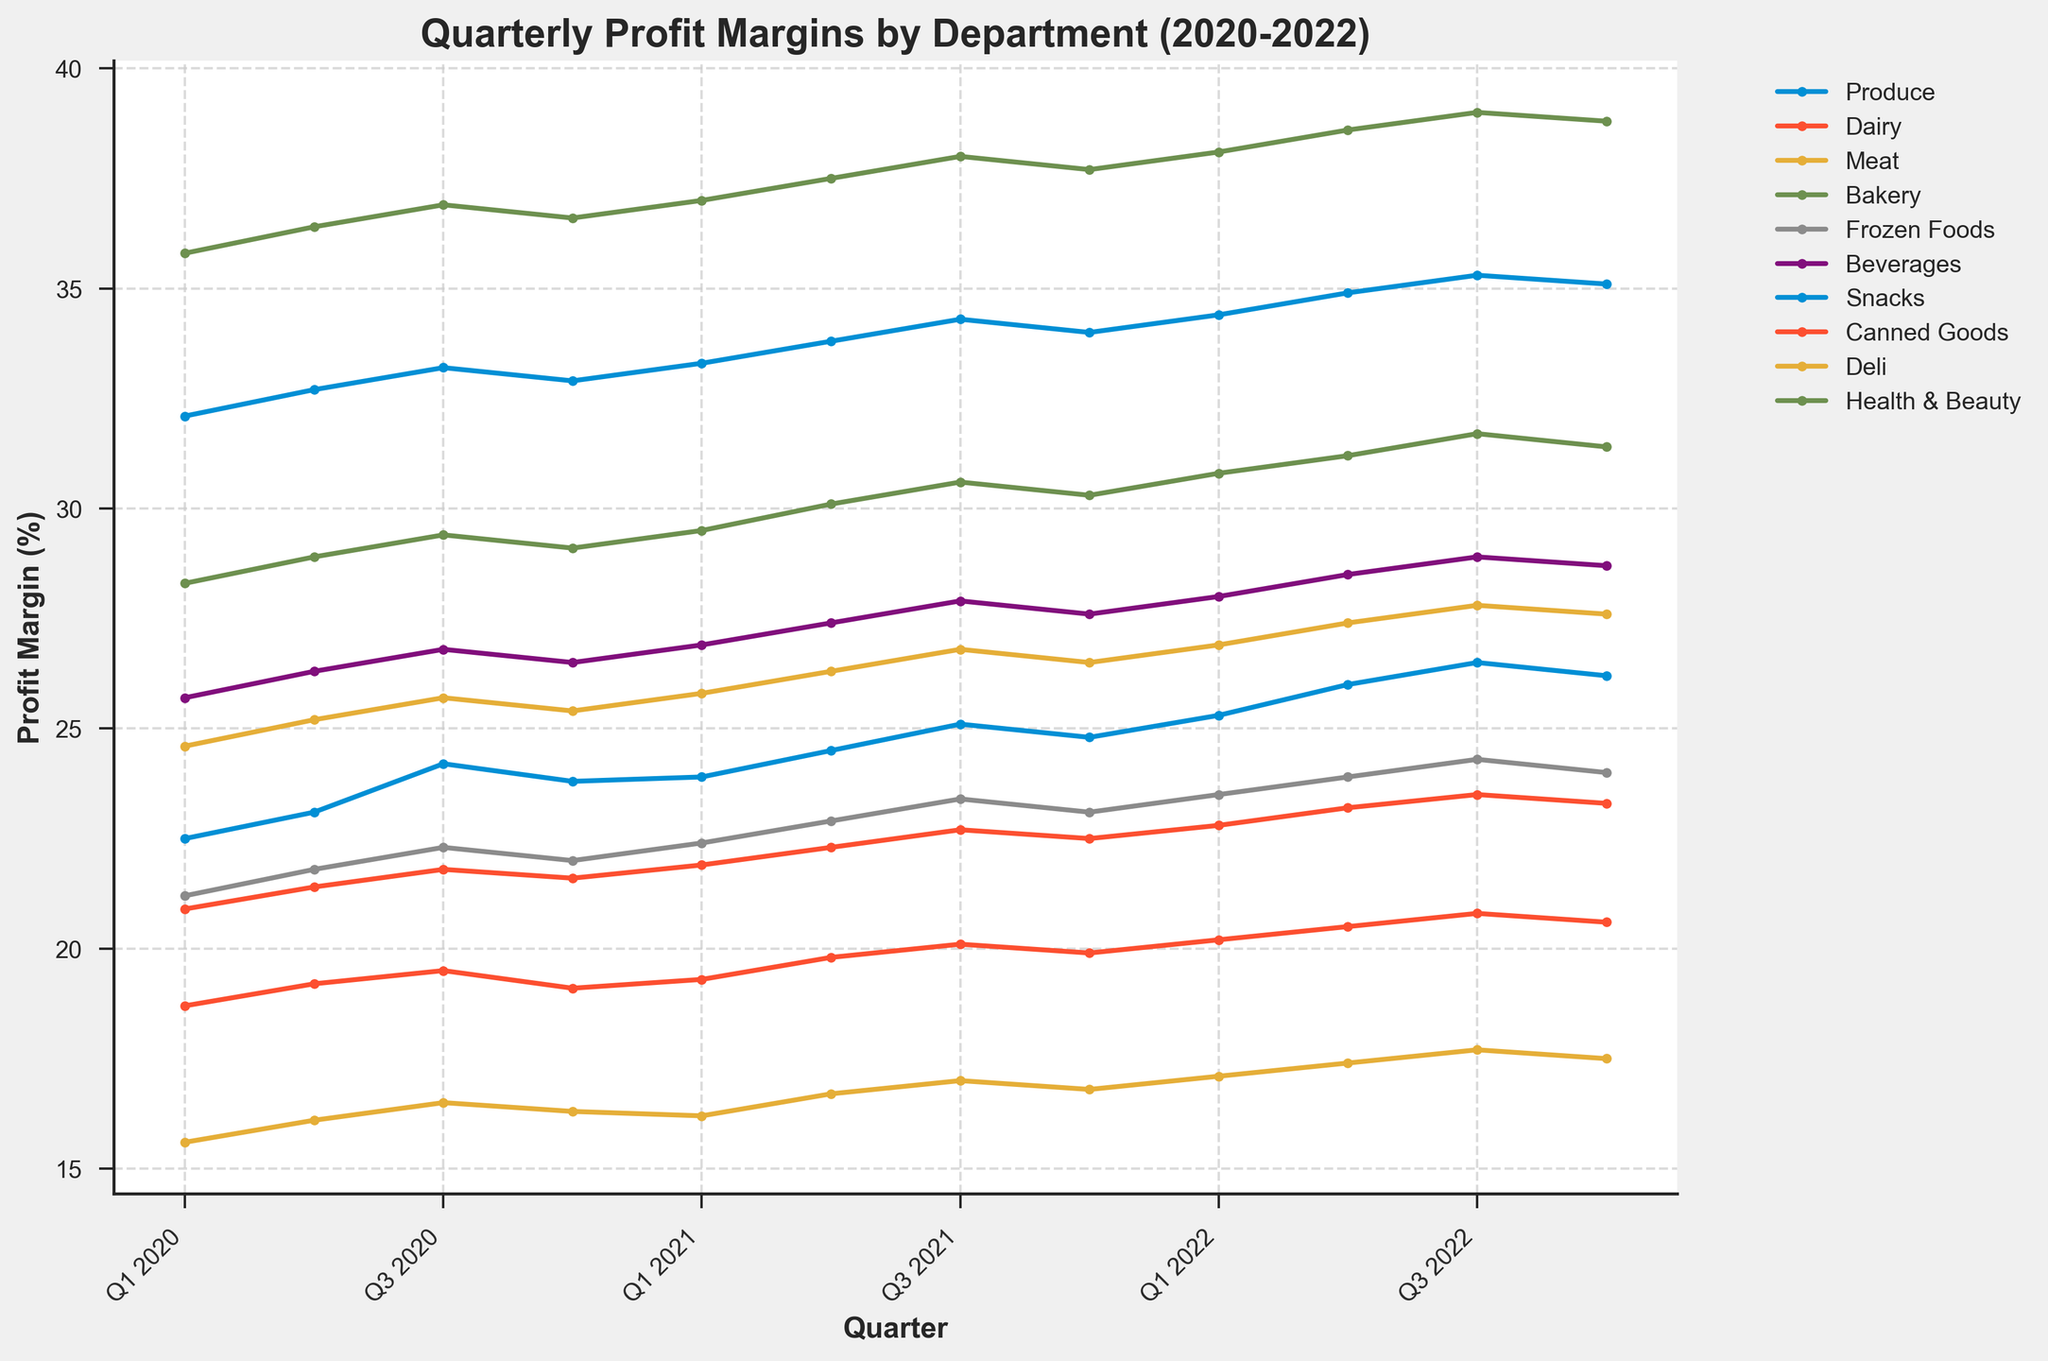What department had the highest profit margin in Q4 2021? Look for the department with the highest value in Q4 2021 on the plot. The Health & Beauty department has the highest line segment at that point.
Answer: Health & Beauty Which department showed the most consistent increase in profit margins over the 3 years? Look for department lines that show a steady upward trend without significant drops. The Health & Beauty line shows a consistent increase from Q1 2020 to Q4 2022.
Answer: Health & Beauty What is the difference in profit margins between the Snacks and Meat departments in Q3 2022? Find the profit margins for Snacks and Meat in Q3 2022 and subtract the Meat margin from the Snacks margin. Snacks: 35.3, Meat: 17.7. Difference = 35.3 - 17.7 = 17.6
Answer: 17.6 Which department has the steepest increase in profit margin from Q1 2020 to Q4 2022? Calculate the difference between Q1 2020 and Q4 2022 for each department. The department with the highest difference has the steepest increase. Health & Beauty: 38.8 - 35.8 = 3.0, Produce: 26.2 - 22.5 = 3.7, etc. The Snacks department shows the steepest increase (35.1 - 32.1 = 3).
Answer: Snacks Did any department show a decrease in profit margin at any point between Q1 2020 and Q4 2022? Look at each department’s profit margin line to see if any segment slopes downward. The Meat and Dairy departments both show a decrease between some quarters.
Answer: Yes Which quarter saw the highest average profit margin across all departments in 2022? To find the average profit margin for each quarter in 2022, sum the values of all departments for each quarter and divide by the number of departments (10). The highest average value indicates the highest average profit margin quarter.
Answer: Q3 2022 In which quarter did the Deli department reach its highest profit margin, and what was the value? Find the highest point on the Deli department's line and identify the corresponding quarter and value. For Deli, the highest value is in Q3 2022 with 27.8.
Answer: Q3 2022, 27.8 How did the profit margin for the Beverages department change from Q1 2020 to Q4 2020? Subtract the profit margin of Q1 2020 from Q4 2020 for the Beverages department. Beverages: 26.5 - 25.7 = 0.8
Answer: Increased by 0.8 Which department had the lowest profit margin in each year, and what were those values? Identify the lowest profit margin for each year by comparing quarterly values, and find the respective departments. For 2020, Meat had the lowest at 15.6 (Q1). For 2021, Meat at 16.2 (Q1). For 2022, Meat at 17.1 (Q1).
Answer: 2020: Meat, 15.6; 2021: Meat, 16.2; 2022: Meat, 17.1 